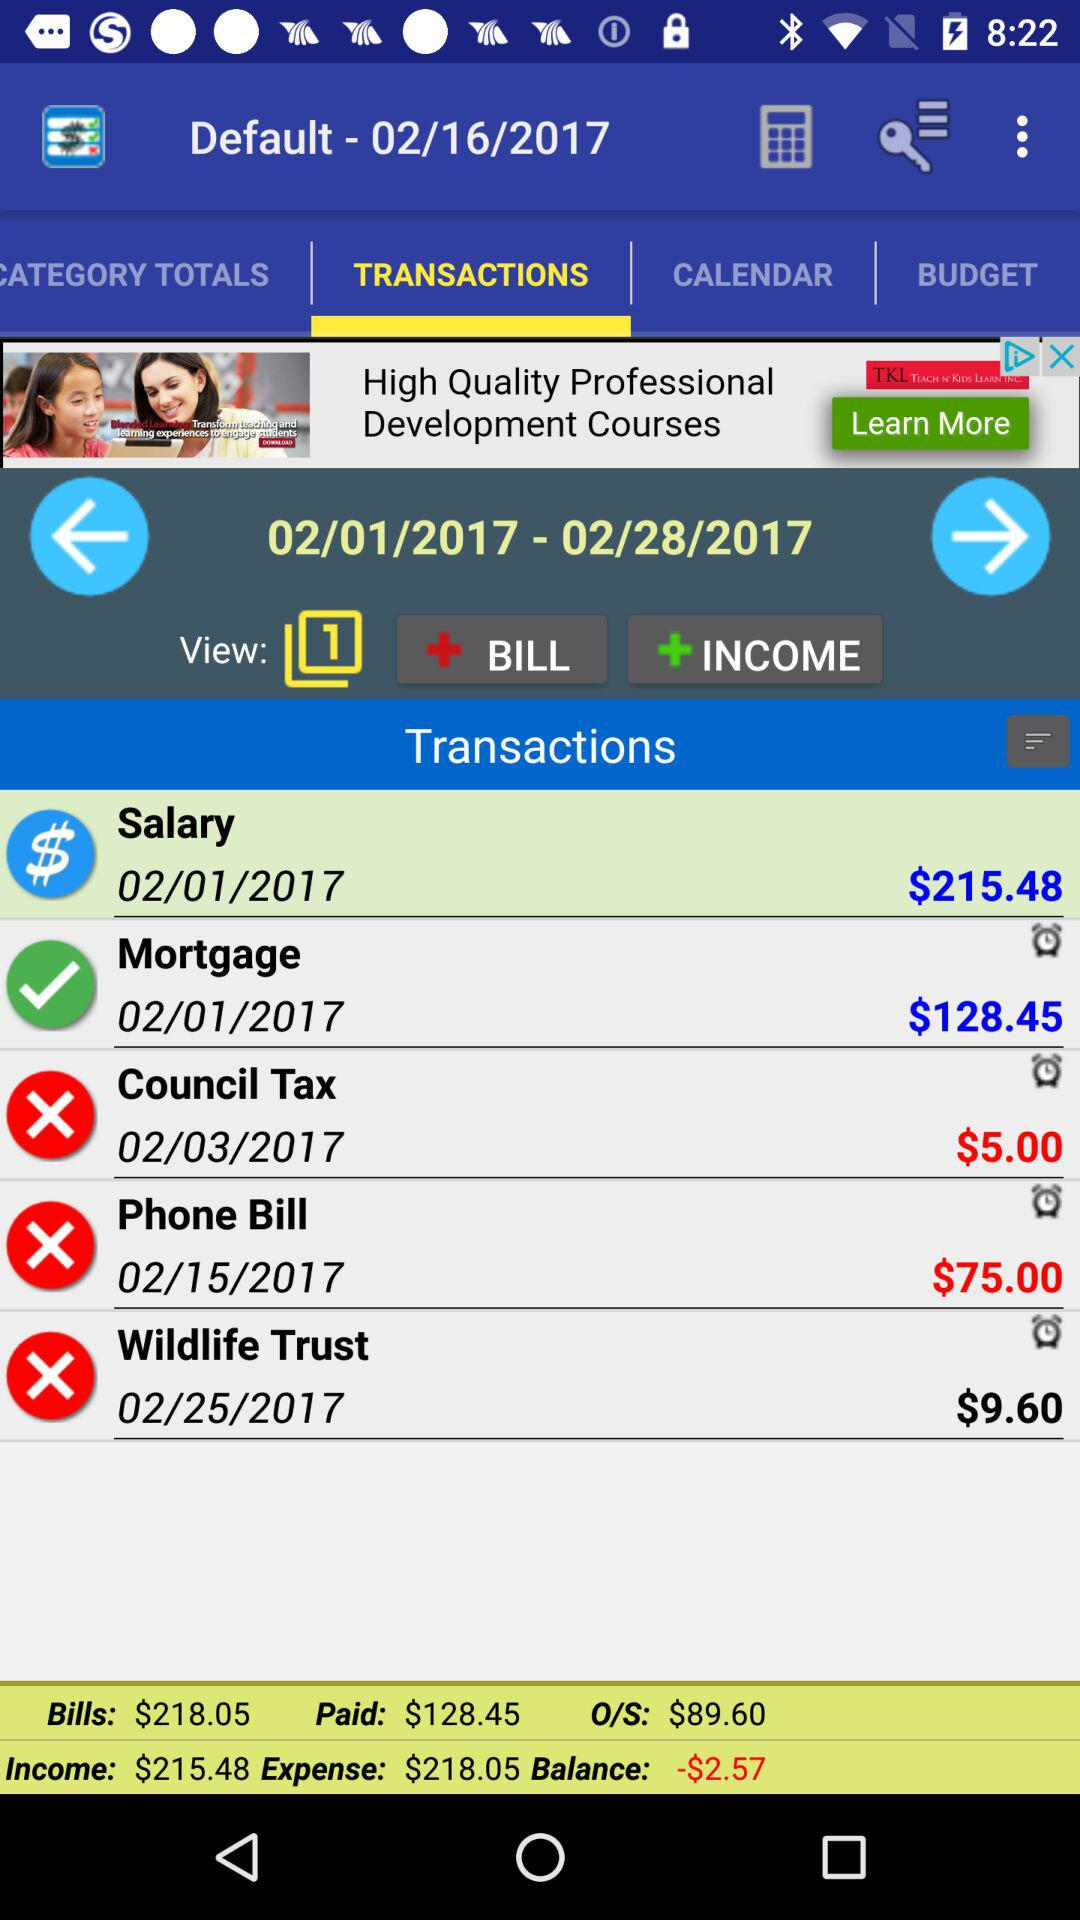What is the council tax amount? The council tax amount is $5.00. 